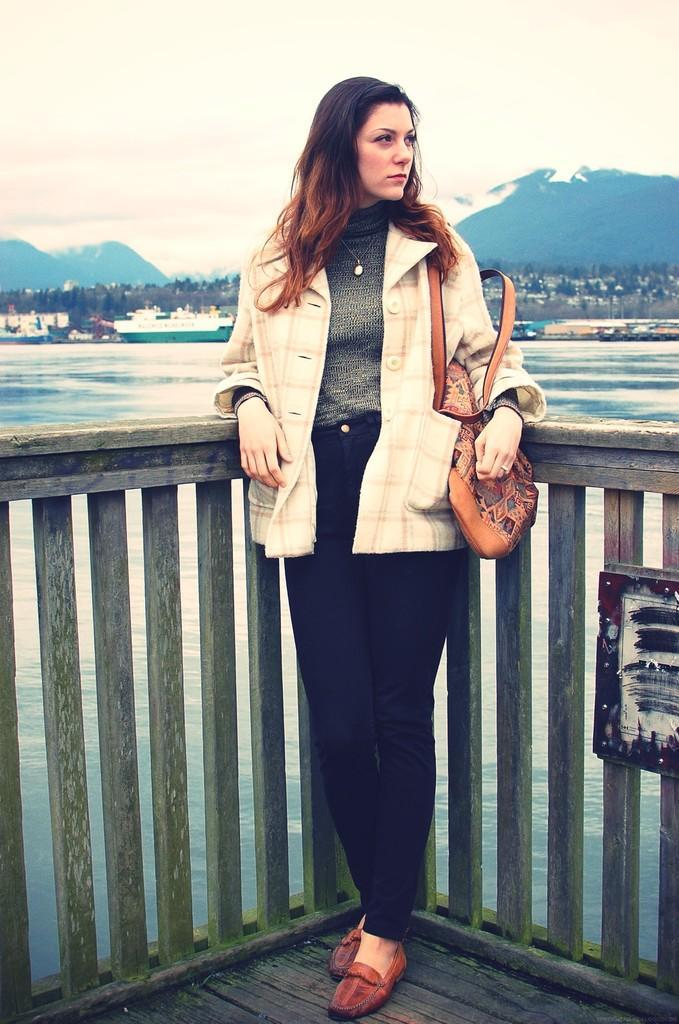Can you describe this image briefly? In this image there is a lady holding a bag and standing on the bridge, there are few ships in the water, few trees, few mountains and the sky. 